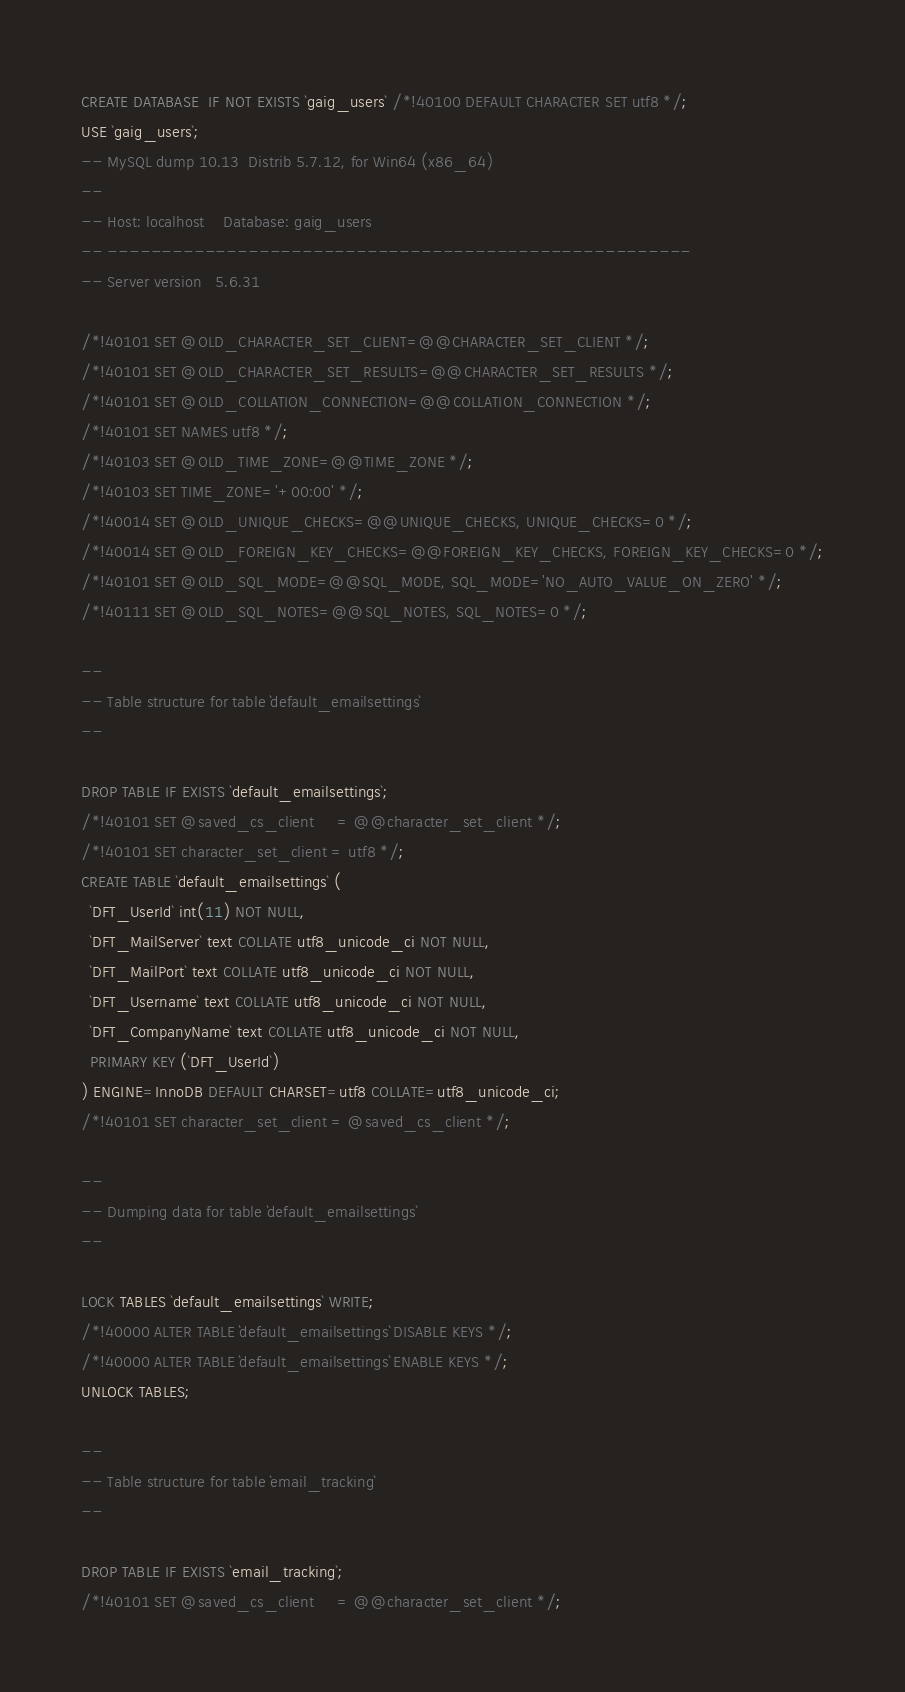<code> <loc_0><loc_0><loc_500><loc_500><_SQL_>CREATE DATABASE  IF NOT EXISTS `gaig_users` /*!40100 DEFAULT CHARACTER SET utf8 */;
USE `gaig_users`;
-- MySQL dump 10.13  Distrib 5.7.12, for Win64 (x86_64)
--
-- Host: localhost    Database: gaig_users
-- ------------------------------------------------------
-- Server version	5.6.31

/*!40101 SET @OLD_CHARACTER_SET_CLIENT=@@CHARACTER_SET_CLIENT */;
/*!40101 SET @OLD_CHARACTER_SET_RESULTS=@@CHARACTER_SET_RESULTS */;
/*!40101 SET @OLD_COLLATION_CONNECTION=@@COLLATION_CONNECTION */;
/*!40101 SET NAMES utf8 */;
/*!40103 SET @OLD_TIME_ZONE=@@TIME_ZONE */;
/*!40103 SET TIME_ZONE='+00:00' */;
/*!40014 SET @OLD_UNIQUE_CHECKS=@@UNIQUE_CHECKS, UNIQUE_CHECKS=0 */;
/*!40014 SET @OLD_FOREIGN_KEY_CHECKS=@@FOREIGN_KEY_CHECKS, FOREIGN_KEY_CHECKS=0 */;
/*!40101 SET @OLD_SQL_MODE=@@SQL_MODE, SQL_MODE='NO_AUTO_VALUE_ON_ZERO' */;
/*!40111 SET @OLD_SQL_NOTES=@@SQL_NOTES, SQL_NOTES=0 */;

--
-- Table structure for table `default_emailsettings`
--

DROP TABLE IF EXISTS `default_emailsettings`;
/*!40101 SET @saved_cs_client     = @@character_set_client */;
/*!40101 SET character_set_client = utf8 */;
CREATE TABLE `default_emailsettings` (
  `DFT_UserId` int(11) NOT NULL,
  `DFT_MailServer` text COLLATE utf8_unicode_ci NOT NULL,
  `DFT_MailPort` text COLLATE utf8_unicode_ci NOT NULL,
  `DFT_Username` text COLLATE utf8_unicode_ci NOT NULL,
  `DFT_CompanyName` text COLLATE utf8_unicode_ci NOT NULL,
  PRIMARY KEY (`DFT_UserId`)
) ENGINE=InnoDB DEFAULT CHARSET=utf8 COLLATE=utf8_unicode_ci;
/*!40101 SET character_set_client = @saved_cs_client */;

--
-- Dumping data for table `default_emailsettings`
--

LOCK TABLES `default_emailsettings` WRITE;
/*!40000 ALTER TABLE `default_emailsettings` DISABLE KEYS */;
/*!40000 ALTER TABLE `default_emailsettings` ENABLE KEYS */;
UNLOCK TABLES;

--
-- Table structure for table `email_tracking`
--

DROP TABLE IF EXISTS `email_tracking`;
/*!40101 SET @saved_cs_client     = @@character_set_client */;</code> 